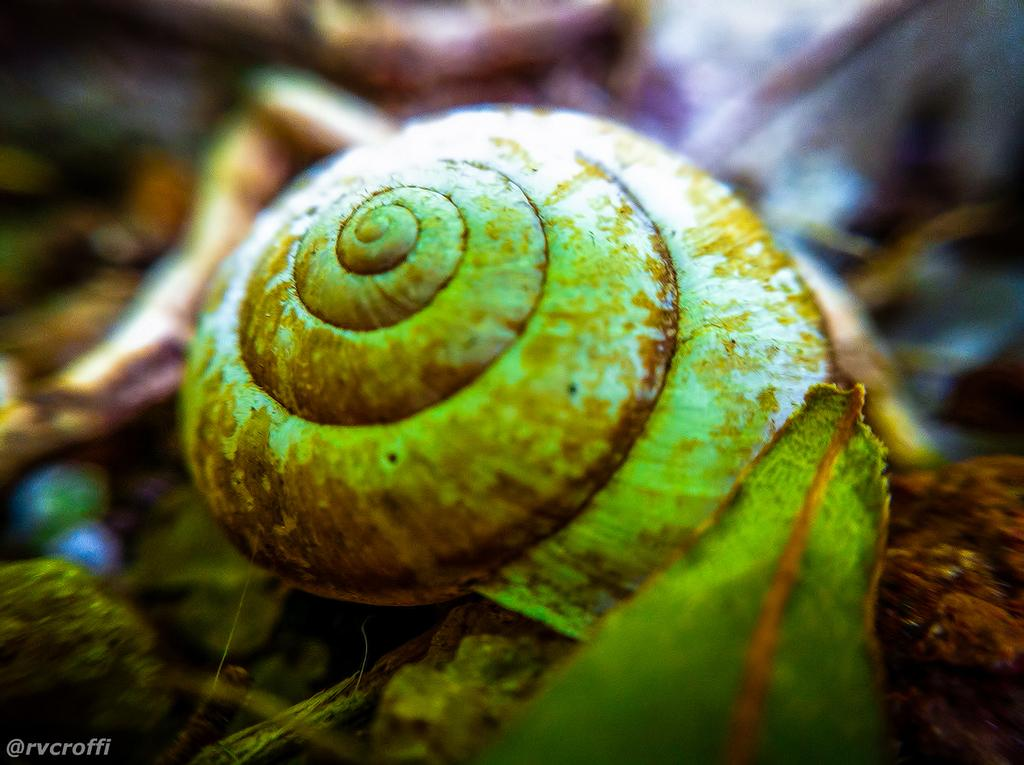What is the main subject of the image? There is a snail in the image. What else can be seen in the image besides the snail? There is a leaf in the image. How would you describe the overall appearance of the image? The surroundings of the image are blurred. Is there any additional information or marking on the image? There is a watermark on the bottom left side of the image. What type of dolls are performing on the stage in the image? There is no stage or dolls present in the image; it features a snail and a leaf with blurred surroundings. 